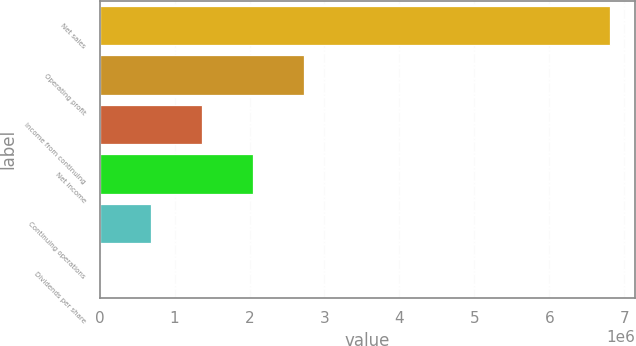Convert chart. <chart><loc_0><loc_0><loc_500><loc_500><bar_chart><fcel>Net sales<fcel>Operating profit<fcel>Income from continuing<fcel>Net income<fcel>Continuing operations<fcel>Dividends per share<nl><fcel>6.80396e+06<fcel>2.72158e+06<fcel>1.36079e+06<fcel>2.04119e+06<fcel>680396<fcel>0.6<nl></chart> 